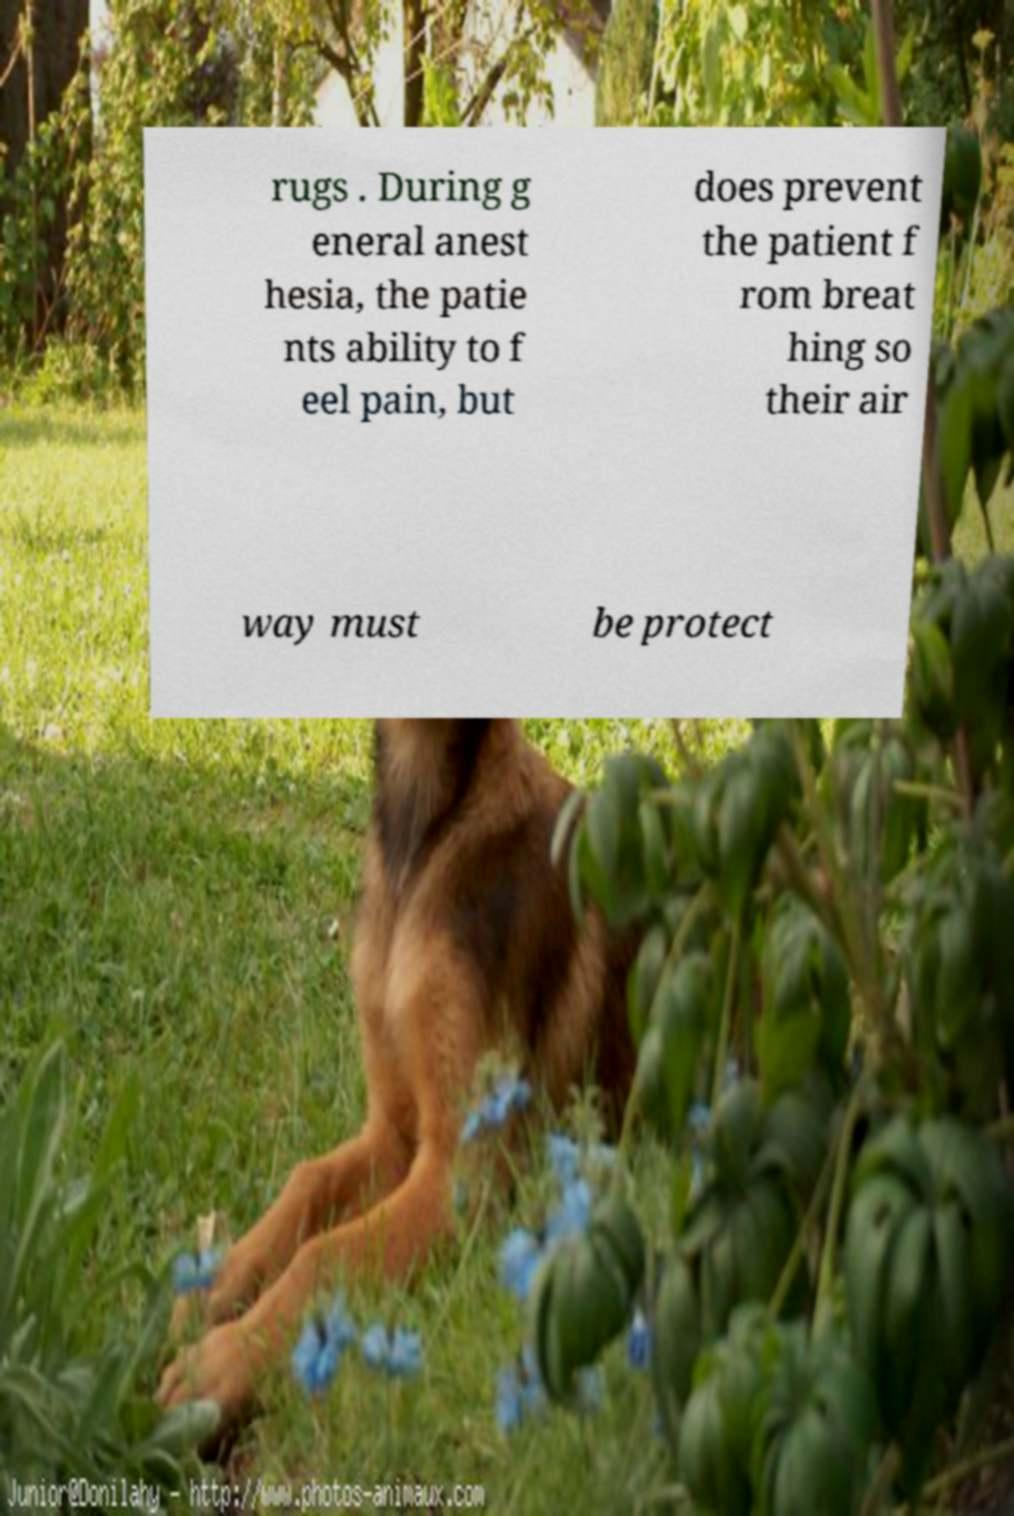Can you read and provide the text displayed in the image?This photo seems to have some interesting text. Can you extract and type it out for me? rugs . During g eneral anest hesia, the patie nts ability to f eel pain, but does prevent the patient f rom breat hing so their air way must be protect 